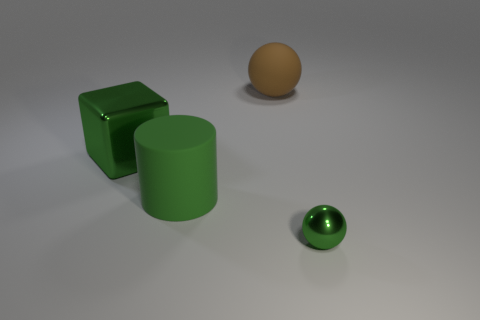Add 3 tiny green metal objects. How many objects exist? 7 Subtract 0 cyan cylinders. How many objects are left? 4 Subtract all cylinders. How many objects are left? 3 Subtract all tiny metal things. Subtract all cylinders. How many objects are left? 2 Add 2 large things. How many large things are left? 5 Add 4 cylinders. How many cylinders exist? 5 